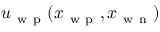<formula> <loc_0><loc_0><loc_500><loc_500>u _ { w p } ( x _ { w p } , x _ { w n } )</formula> 